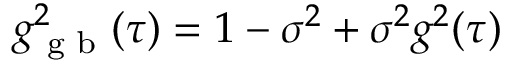<formula> <loc_0><loc_0><loc_500><loc_500>g _ { g b } ^ { 2 } ( \tau ) = 1 - \sigma ^ { 2 } + \sigma ^ { 2 } g ^ { 2 } ( \tau )</formula> 